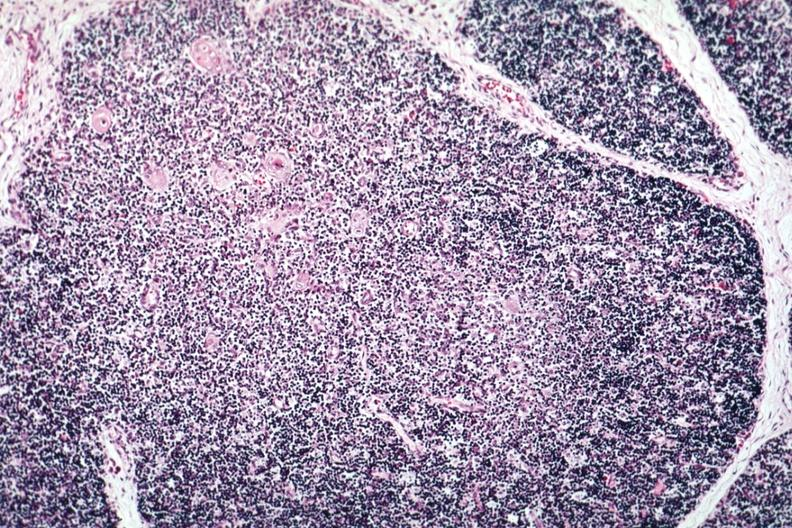what is present?
Answer the question using a single word or phrase. Thymus 